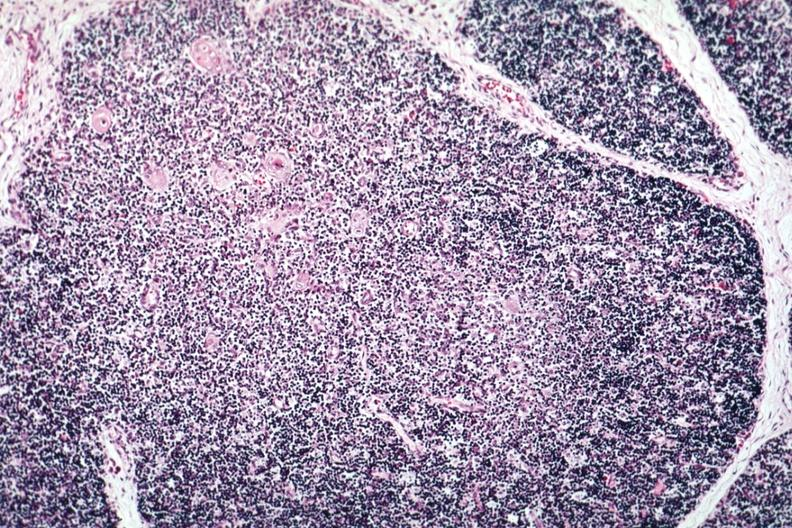what is present?
Answer the question using a single word or phrase. Thymus 